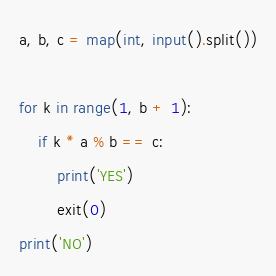<code> <loc_0><loc_0><loc_500><loc_500><_Python_>a, b, c = map(int, input().split())

for k in range(1, b + 1):
    if k * a % b == c:
        print('YES')
        exit(0)
print('NO')
</code> 